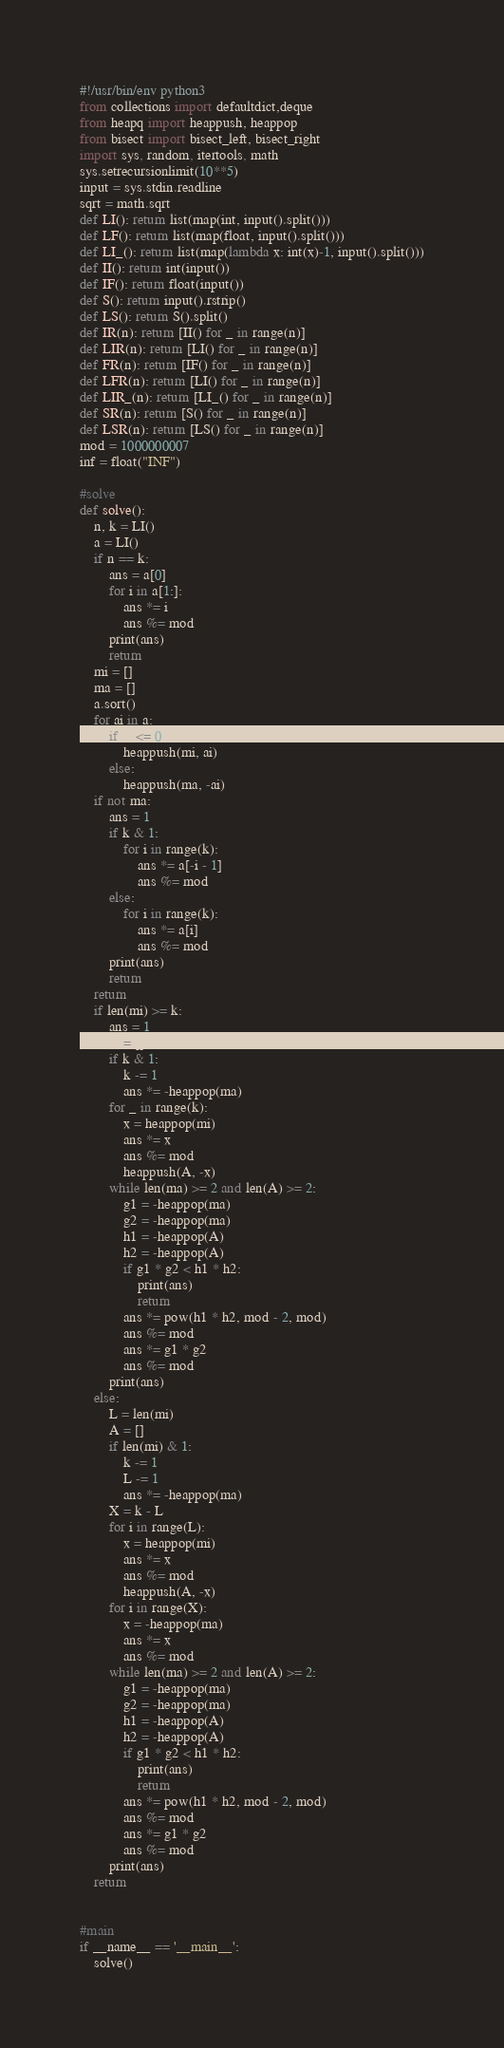Convert code to text. <code><loc_0><loc_0><loc_500><loc_500><_Python_>#!/usr/bin/env python3
from collections import defaultdict,deque
from heapq import heappush, heappop
from bisect import bisect_left, bisect_right
import sys, random, itertools, math
sys.setrecursionlimit(10**5)
input = sys.stdin.readline
sqrt = math.sqrt
def LI(): return list(map(int, input().split()))
def LF(): return list(map(float, input().split()))
def LI_(): return list(map(lambda x: int(x)-1, input().split()))
def II(): return int(input())
def IF(): return float(input())
def S(): return input().rstrip()
def LS(): return S().split()
def IR(n): return [II() for _ in range(n)]
def LIR(n): return [LI() for _ in range(n)]
def FR(n): return [IF() for _ in range(n)]
def LFR(n): return [LI() for _ in range(n)]
def LIR_(n): return [LI_() for _ in range(n)]
def SR(n): return [S() for _ in range(n)]
def LSR(n): return [LS() for _ in range(n)]
mod = 1000000007
inf = float("INF")

#solve
def solve():
    n, k = LI()
    a = LI()
    if n == k:
        ans = a[0]
        for i in a[1:]:
            ans *= i
            ans %= mod
        print(ans)
        return
    mi = []
    ma = []
    a.sort()
    for ai in a:
        if ai <= 0:
            heappush(mi, ai)
        else:
            heappush(ma, -ai)
    if not ma:
        ans = 1
        if k & 1:
            for i in range(k):
                ans *= a[-i - 1]
                ans %= mod
        else:
            for i in range(k):
                ans *= a[i]
                ans %= mod
        print(ans)
        return
    return
    if len(mi) >= k:
        ans = 1
        A = []
        if k & 1:
            k -= 1
            ans *= -heappop(ma)
        for _ in range(k):
            x = heappop(mi)
            ans *= x
            ans %= mod
            heappush(A, -x)
        while len(ma) >= 2 and len(A) >= 2:
            g1 = -heappop(ma)
            g2 = -heappop(ma)
            h1 = -heappop(A)
            h2 = -heappop(A)
            if g1 * g2 < h1 * h2:
                print(ans)
                return
            ans *= pow(h1 * h2, mod - 2, mod)
            ans %= mod
            ans *= g1 * g2
            ans %= mod
        print(ans)
    else:
        L = len(mi)
        A = []
        if len(mi) & 1:
            k -= 1
            L -= 1
            ans *= -heappop(ma)
        X = k - L
        for i in range(L):
            x = heappop(mi)
            ans *= x
            ans %= mod
            heappush(A, -x)
        for i in range(X):
            x = -heappop(ma)
            ans *= x
            ans %= mod
        while len(ma) >= 2 and len(A) >= 2:
            g1 = -heappop(ma)
            g2 = -heappop(ma)
            h1 = -heappop(A)
            h2 = -heappop(A)
            if g1 * g2 < h1 * h2:
                print(ans)
                return
            ans *= pow(h1 * h2, mod - 2, mod)
            ans %= mod
            ans *= g1 * g2
            ans %= mod
        print(ans)
    return


#main
if __name__ == '__main__':
    solve()
</code> 